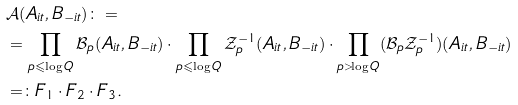<formula> <loc_0><loc_0><loc_500><loc_500>& \mathcal { A } ( A _ { i t } , B _ { - i t } ) \colon = \\ & = \prod _ { p \leqslant \log Q } \mathcal { B } _ { p } ( A _ { i t } , B _ { - i t } ) \cdot \prod _ { p \leqslant \log Q } \mathcal { Z } _ { p } ^ { - 1 } ( A _ { i t } , B _ { - i t } ) \cdot \prod _ { p > \log Q } ( \mathcal { B } _ { p } \mathcal { Z } _ { p } ^ { - 1 } ) ( A _ { i t } , B _ { - i t } ) \\ & = \colon F _ { 1 } \cdot F _ { 2 } \cdot F _ { 3 } .</formula> 